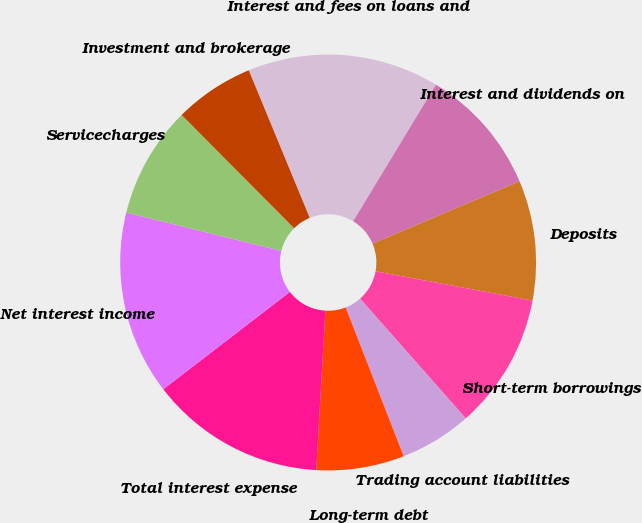Convert chart to OTSL. <chart><loc_0><loc_0><loc_500><loc_500><pie_chart><fcel>Interest and fees on loans and<fcel>Interest and dividends on<fcel>Deposits<fcel>Short-term borrowings<fcel>Trading account liabilities<fcel>Long-term debt<fcel>Total interest expense<fcel>Net interest income<fcel>Servicecharges<fcel>Investment and brokerage<nl><fcel>14.91%<fcel>9.94%<fcel>9.32%<fcel>10.56%<fcel>5.59%<fcel>6.83%<fcel>13.66%<fcel>14.29%<fcel>8.7%<fcel>6.21%<nl></chart> 